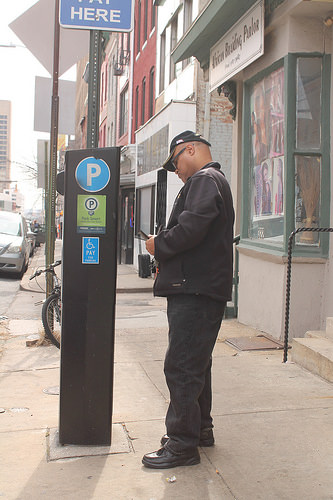<image>
Is there a man to the left of the building? No. The man is not to the left of the building. From this viewpoint, they have a different horizontal relationship. Is there a window in front of the man? No. The window is not in front of the man. The spatial positioning shows a different relationship between these objects. 